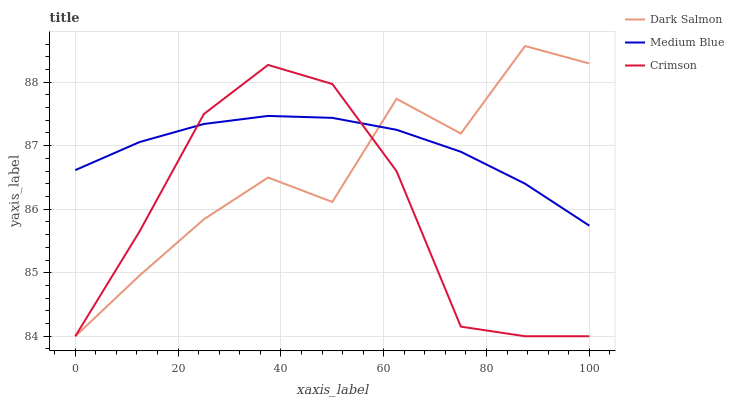Does Crimson have the minimum area under the curve?
Answer yes or no. Yes. Does Medium Blue have the maximum area under the curve?
Answer yes or no. Yes. Does Dark Salmon have the minimum area under the curve?
Answer yes or no. No. Does Dark Salmon have the maximum area under the curve?
Answer yes or no. No. Is Medium Blue the smoothest?
Answer yes or no. Yes. Is Dark Salmon the roughest?
Answer yes or no. Yes. Is Dark Salmon the smoothest?
Answer yes or no. No. Is Medium Blue the roughest?
Answer yes or no. No. Does Crimson have the lowest value?
Answer yes or no. Yes. Does Medium Blue have the lowest value?
Answer yes or no. No. Does Dark Salmon have the highest value?
Answer yes or no. Yes. Does Medium Blue have the highest value?
Answer yes or no. No. Does Medium Blue intersect Crimson?
Answer yes or no. Yes. Is Medium Blue less than Crimson?
Answer yes or no. No. Is Medium Blue greater than Crimson?
Answer yes or no. No. 